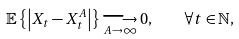Convert formula to latex. <formula><loc_0><loc_0><loc_500><loc_500>\mathbb { E } \left \{ \left | X _ { t } - X _ { t } ^ { A } \right | \right \} \underset { A \rightarrow \infty } { \longrightarrow } 0 , \quad \forall t \in \mathbb { N } ,</formula> 